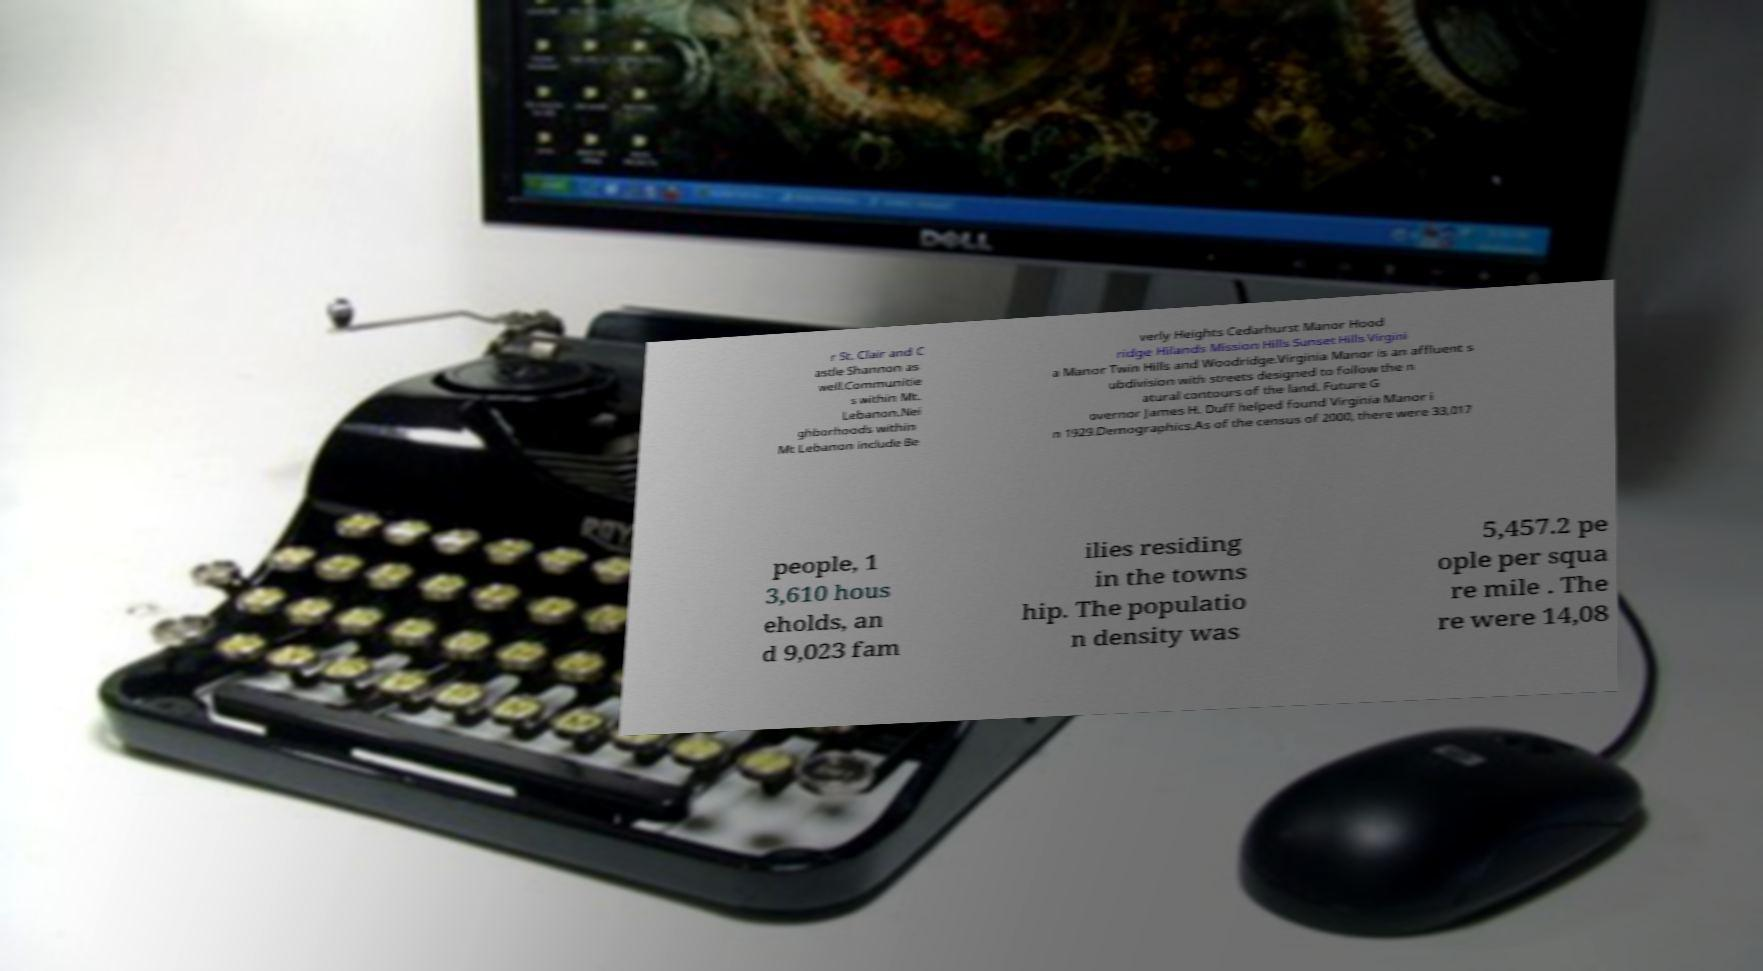For documentation purposes, I need the text within this image transcribed. Could you provide that? r St. Clair and C astle Shannon as well.Communitie s within Mt. Lebanon.Nei ghborhoods within Mt Lebanon include Be verly Heights Cedarhurst Manor Hood ridge Hilands Mission Hills Sunset Hills Virgini a Manor Twin Hills and Woodridge.Virginia Manor is an affluent s ubdivision with streets designed to follow the n atural contours of the land. Future G overnor James H. Duff helped found Virginia Manor i n 1929.Demographics.As of the census of 2000, there were 33,017 people, 1 3,610 hous eholds, an d 9,023 fam ilies residing in the towns hip. The populatio n density was 5,457.2 pe ople per squa re mile . The re were 14,08 